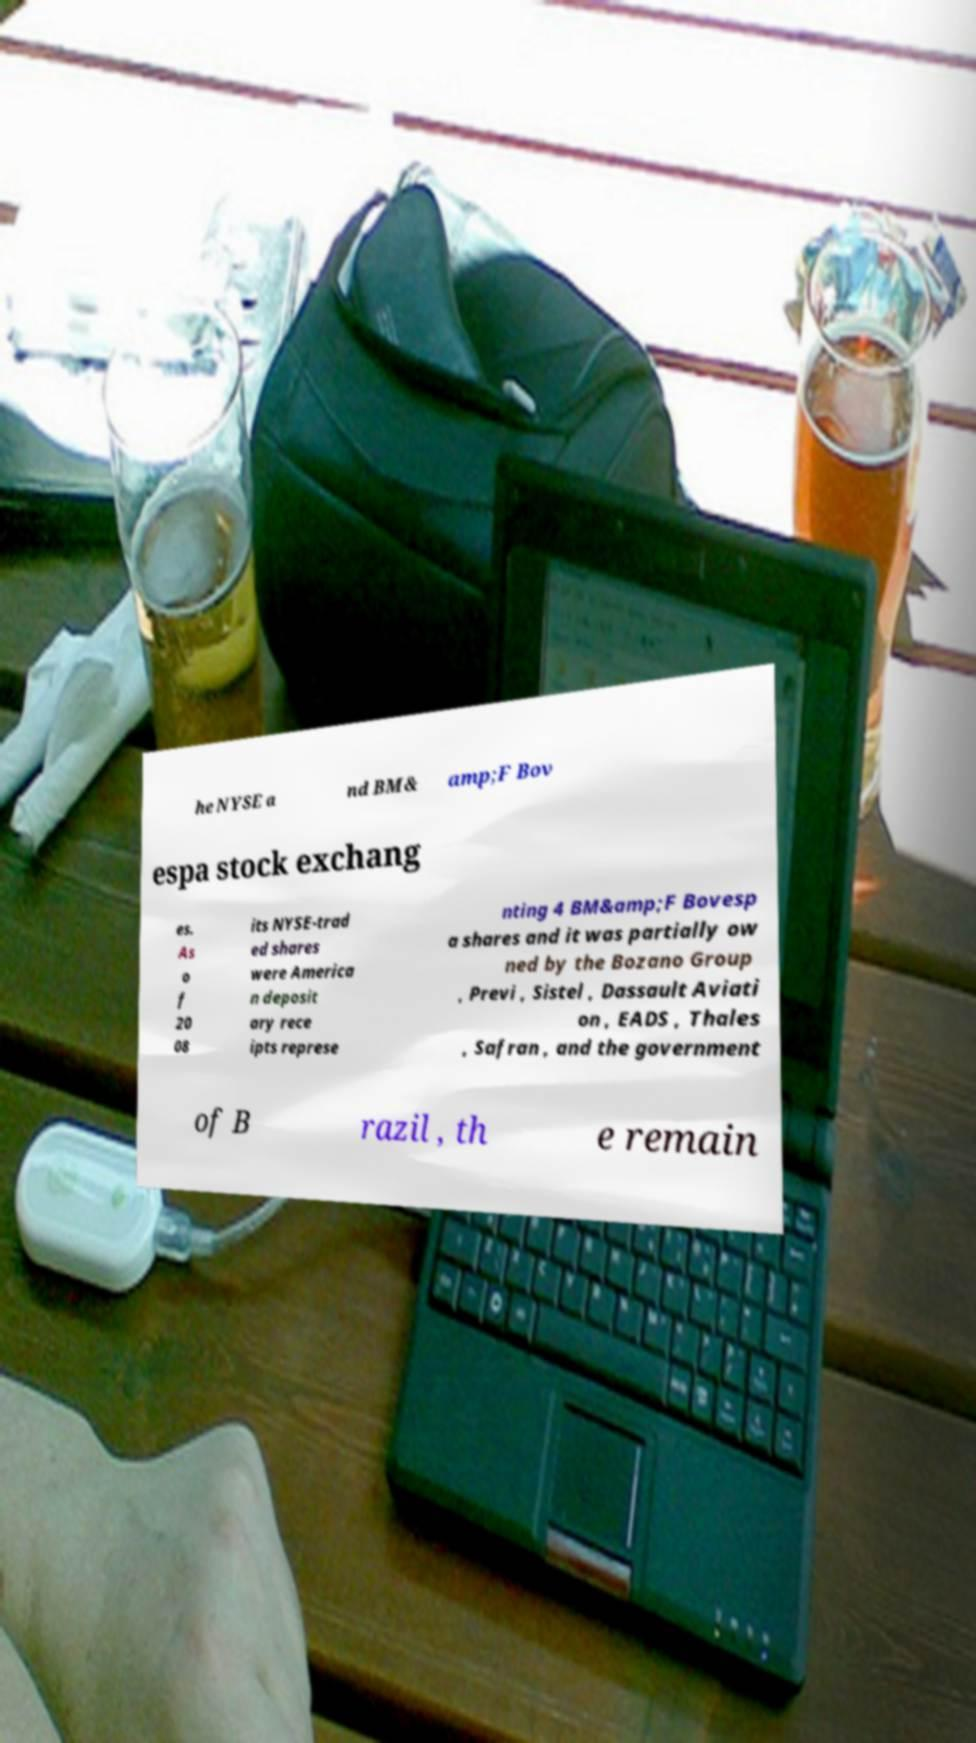Could you extract and type out the text from this image? he NYSE a nd BM& amp;F Bov espa stock exchang es. As o f 20 08 its NYSE-trad ed shares were America n deposit ary rece ipts represe nting 4 BM&amp;F Bovesp a shares and it was partially ow ned by the Bozano Group , Previ , Sistel , Dassault Aviati on , EADS , Thales , Safran , and the government of B razil , th e remain 